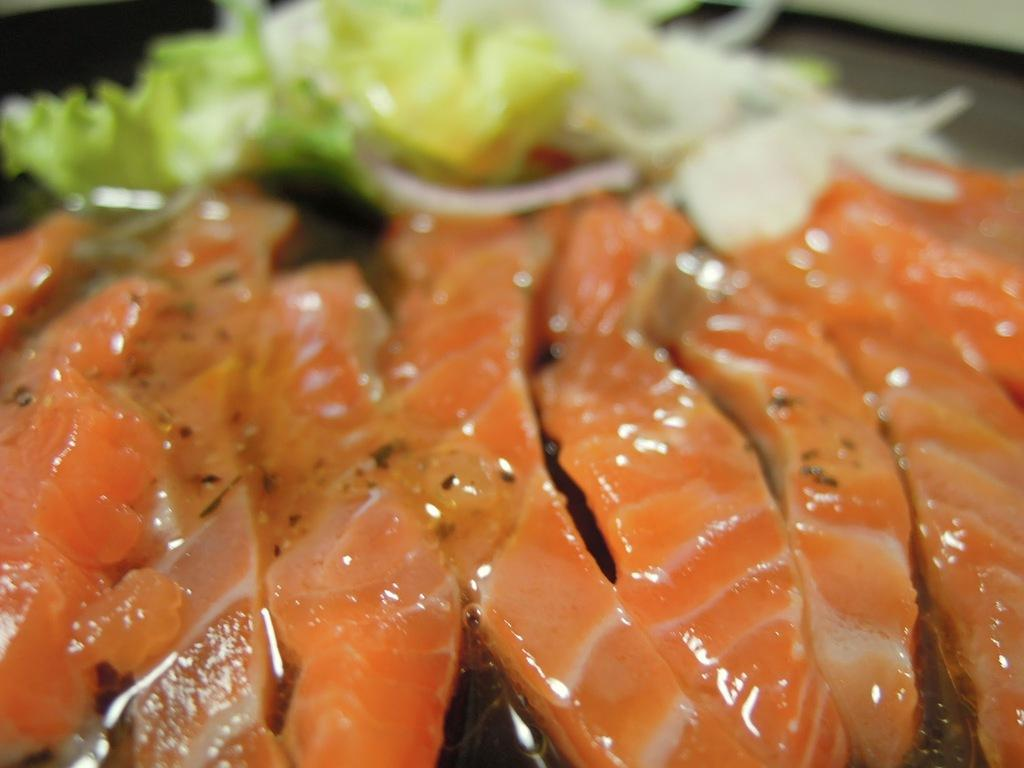What type of food can be seen in the image? There is meat in the image. Are there any other food items present besides the meat? Yes, there is at least one other food item in the image. Can you describe the background of the image? The background of the image is blurred. What type of notebook is being used by the duck in the image? There is no duck or notebook present in the image. 